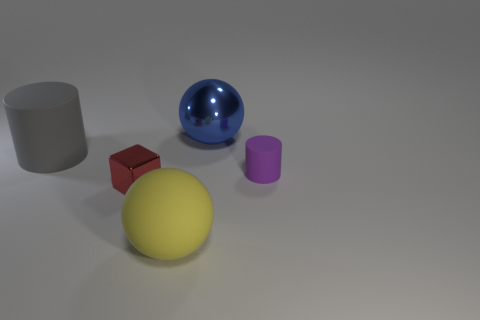Add 1 gray cylinders. How many objects exist? 6 Subtract all blocks. How many objects are left? 4 Add 5 big blue shiny things. How many big blue shiny things are left? 6 Add 1 small red blocks. How many small red blocks exist? 2 Subtract 1 red cubes. How many objects are left? 4 Subtract all small purple spheres. Subtract all blue shiny balls. How many objects are left? 4 